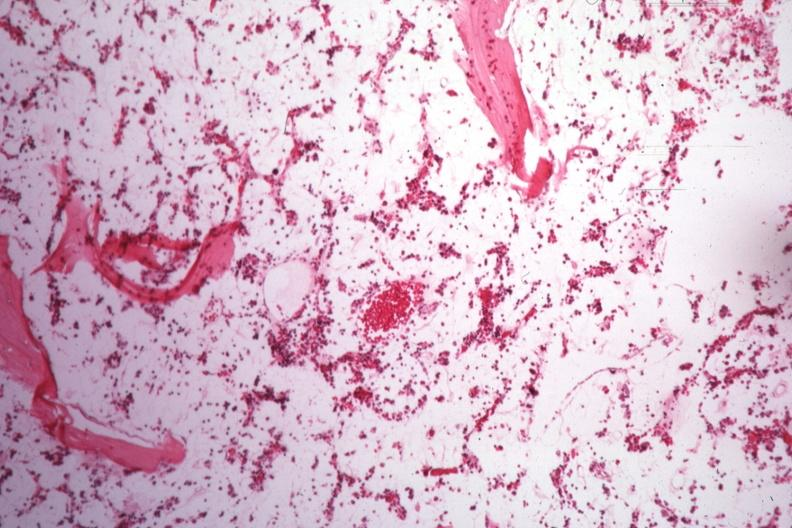s hematologic present?
Answer the question using a single word or phrase. Yes 